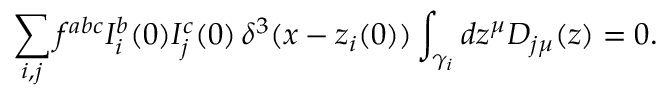Convert formula to latex. <formula><loc_0><loc_0><loc_500><loc_500>\sum _ { i , j } f ^ { a b c } I _ { i } ^ { b } ( 0 ) I _ { j } ^ { c } ( 0 ) \, \delta ^ { 3 } ( x - z _ { i } ( 0 ) ) \int _ { \gamma _ { i } } d z ^ { \mu } D _ { j \mu } ( z ) = 0 .</formula> 